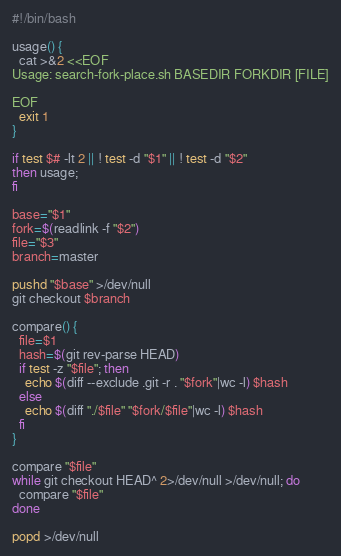<code> <loc_0><loc_0><loc_500><loc_500><_Bash_>#!/bin/bash

usage() {
  cat >&2 <<EOF
Usage: search-fork-place.sh BASEDIR FORKDIR [FILE]

EOF
  exit 1
}

if test $# -lt 2 || ! test -d "$1" || ! test -d "$2"
then usage; 
fi

base="$1"
fork=$(readlink -f "$2")
file="$3"
branch=master

pushd "$base" >/dev/null
git checkout $branch

compare() {
  file=$1
  hash=$(git rev-parse HEAD)
  if test -z "$file"; then
    echo $(diff --exclude .git -r . "$fork"|wc -l) $hash
  else
    echo $(diff "./$file" "$fork/$file"|wc -l) $hash
  fi
}

compare "$file"
while git checkout HEAD^ 2>/dev/null >/dev/null; do 
  compare "$file"
done

popd >/dev/null

</code> 